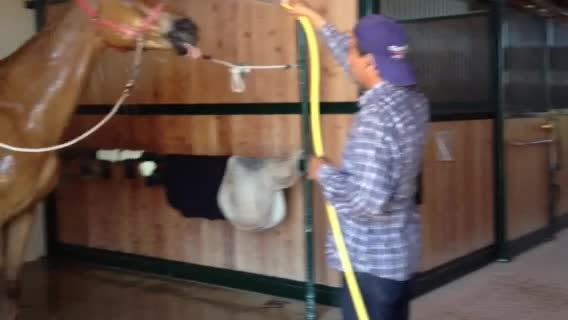Describe the objects in this image and their specific colors. I can see people in gray and darkgray tones and horse in gray, brown, and maroon tones in this image. 